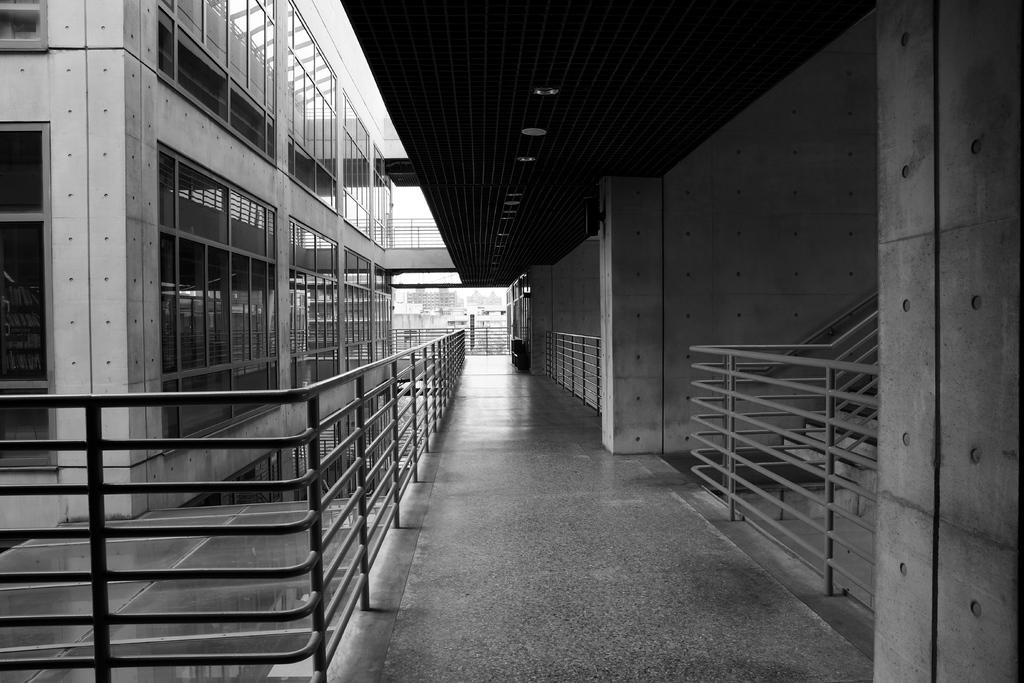What is the color scheme of the image? The image is black and white. What type of building can be seen in the image? There is a building with glass windows in the image. What is located beside the building in the image? There is a fence beside the building in the image. How many people are in the group standing on the floor in the image? There is no group of people or floor visible in the image; it only features a building with glass windows and a fence. 